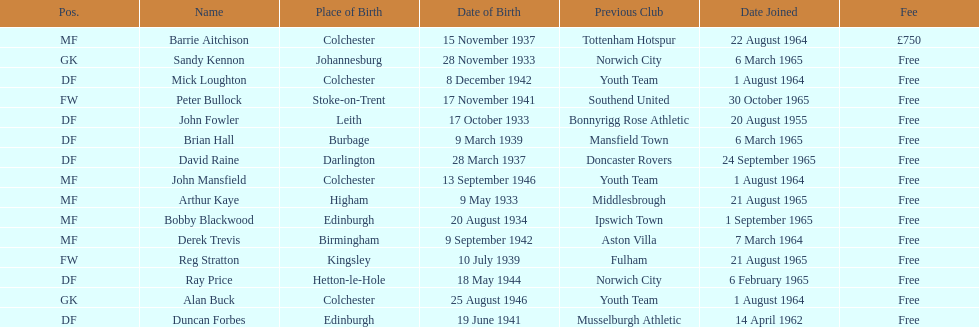What is the other fee listed, besides free? £750. 